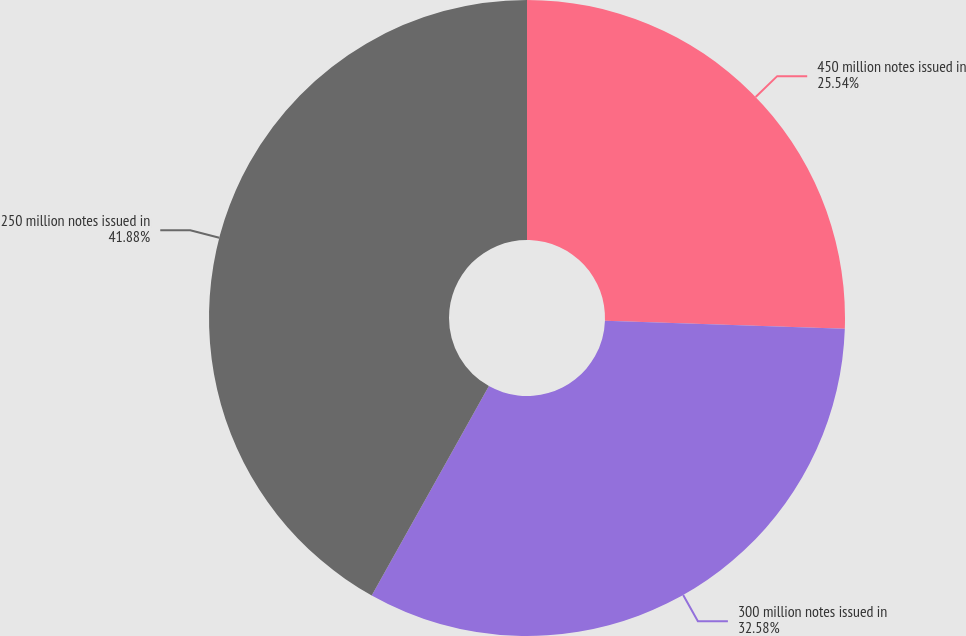Convert chart. <chart><loc_0><loc_0><loc_500><loc_500><pie_chart><fcel>450 million notes issued in<fcel>300 million notes issued in<fcel>250 million notes issued in<nl><fcel>25.54%<fcel>32.58%<fcel>41.88%<nl></chart> 